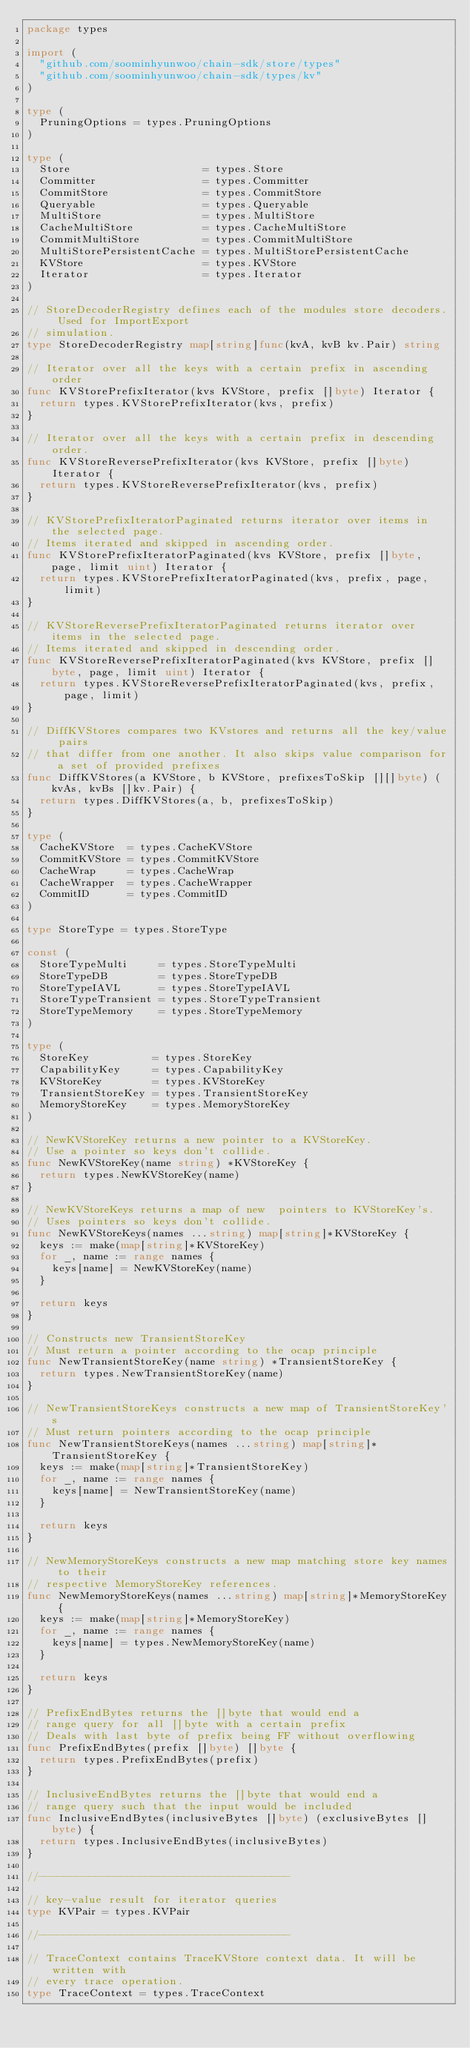Convert code to text. <code><loc_0><loc_0><loc_500><loc_500><_Go_>package types

import (
	"github.com/soominhyunwoo/chain-sdk/store/types"
	"github.com/soominhyunwoo/chain-sdk/types/kv"
)

type (
	PruningOptions = types.PruningOptions
)

type (
	Store                     = types.Store
	Committer                 = types.Committer
	CommitStore               = types.CommitStore
	Queryable                 = types.Queryable
	MultiStore                = types.MultiStore
	CacheMultiStore           = types.CacheMultiStore
	CommitMultiStore          = types.CommitMultiStore
	MultiStorePersistentCache = types.MultiStorePersistentCache
	KVStore                   = types.KVStore
	Iterator                  = types.Iterator
)

// StoreDecoderRegistry defines each of the modules store decoders. Used for ImportExport
// simulation.
type StoreDecoderRegistry map[string]func(kvA, kvB kv.Pair) string

// Iterator over all the keys with a certain prefix in ascending order
func KVStorePrefixIterator(kvs KVStore, prefix []byte) Iterator {
	return types.KVStorePrefixIterator(kvs, prefix)
}

// Iterator over all the keys with a certain prefix in descending order.
func KVStoreReversePrefixIterator(kvs KVStore, prefix []byte) Iterator {
	return types.KVStoreReversePrefixIterator(kvs, prefix)
}

// KVStorePrefixIteratorPaginated returns iterator over items in the selected page.
// Items iterated and skipped in ascending order.
func KVStorePrefixIteratorPaginated(kvs KVStore, prefix []byte, page, limit uint) Iterator {
	return types.KVStorePrefixIteratorPaginated(kvs, prefix, page, limit)
}

// KVStoreReversePrefixIteratorPaginated returns iterator over items in the selected page.
// Items iterated and skipped in descending order.
func KVStoreReversePrefixIteratorPaginated(kvs KVStore, prefix []byte, page, limit uint) Iterator {
	return types.KVStoreReversePrefixIteratorPaginated(kvs, prefix, page, limit)
}

// DiffKVStores compares two KVstores and returns all the key/value pairs
// that differ from one another. It also skips value comparison for a set of provided prefixes
func DiffKVStores(a KVStore, b KVStore, prefixesToSkip [][]byte) (kvAs, kvBs []kv.Pair) {
	return types.DiffKVStores(a, b, prefixesToSkip)
}

type (
	CacheKVStore  = types.CacheKVStore
	CommitKVStore = types.CommitKVStore
	CacheWrap     = types.CacheWrap
	CacheWrapper  = types.CacheWrapper
	CommitID      = types.CommitID
)

type StoreType = types.StoreType

const (
	StoreTypeMulti     = types.StoreTypeMulti
	StoreTypeDB        = types.StoreTypeDB
	StoreTypeIAVL      = types.StoreTypeIAVL
	StoreTypeTransient = types.StoreTypeTransient
	StoreTypeMemory    = types.StoreTypeMemory
)

type (
	StoreKey          = types.StoreKey
	CapabilityKey     = types.CapabilityKey
	KVStoreKey        = types.KVStoreKey
	TransientStoreKey = types.TransientStoreKey
	MemoryStoreKey    = types.MemoryStoreKey
)

// NewKVStoreKey returns a new pointer to a KVStoreKey.
// Use a pointer so keys don't collide.
func NewKVStoreKey(name string) *KVStoreKey {
	return types.NewKVStoreKey(name)
}

// NewKVStoreKeys returns a map of new  pointers to KVStoreKey's.
// Uses pointers so keys don't collide.
func NewKVStoreKeys(names ...string) map[string]*KVStoreKey {
	keys := make(map[string]*KVStoreKey)
	for _, name := range names {
		keys[name] = NewKVStoreKey(name)
	}

	return keys
}

// Constructs new TransientStoreKey
// Must return a pointer according to the ocap principle
func NewTransientStoreKey(name string) *TransientStoreKey {
	return types.NewTransientStoreKey(name)
}

// NewTransientStoreKeys constructs a new map of TransientStoreKey's
// Must return pointers according to the ocap principle
func NewTransientStoreKeys(names ...string) map[string]*TransientStoreKey {
	keys := make(map[string]*TransientStoreKey)
	for _, name := range names {
		keys[name] = NewTransientStoreKey(name)
	}

	return keys
}

// NewMemoryStoreKeys constructs a new map matching store key names to their
// respective MemoryStoreKey references.
func NewMemoryStoreKeys(names ...string) map[string]*MemoryStoreKey {
	keys := make(map[string]*MemoryStoreKey)
	for _, name := range names {
		keys[name] = types.NewMemoryStoreKey(name)
	}

	return keys
}

// PrefixEndBytes returns the []byte that would end a
// range query for all []byte with a certain prefix
// Deals with last byte of prefix being FF without overflowing
func PrefixEndBytes(prefix []byte) []byte {
	return types.PrefixEndBytes(prefix)
}

// InclusiveEndBytes returns the []byte that would end a
// range query such that the input would be included
func InclusiveEndBytes(inclusiveBytes []byte) (exclusiveBytes []byte) {
	return types.InclusiveEndBytes(inclusiveBytes)
}

//----------------------------------------

// key-value result for iterator queries
type KVPair = types.KVPair

//----------------------------------------

// TraceContext contains TraceKVStore context data. It will be written with
// every trace operation.
type TraceContext = types.TraceContext
</code> 